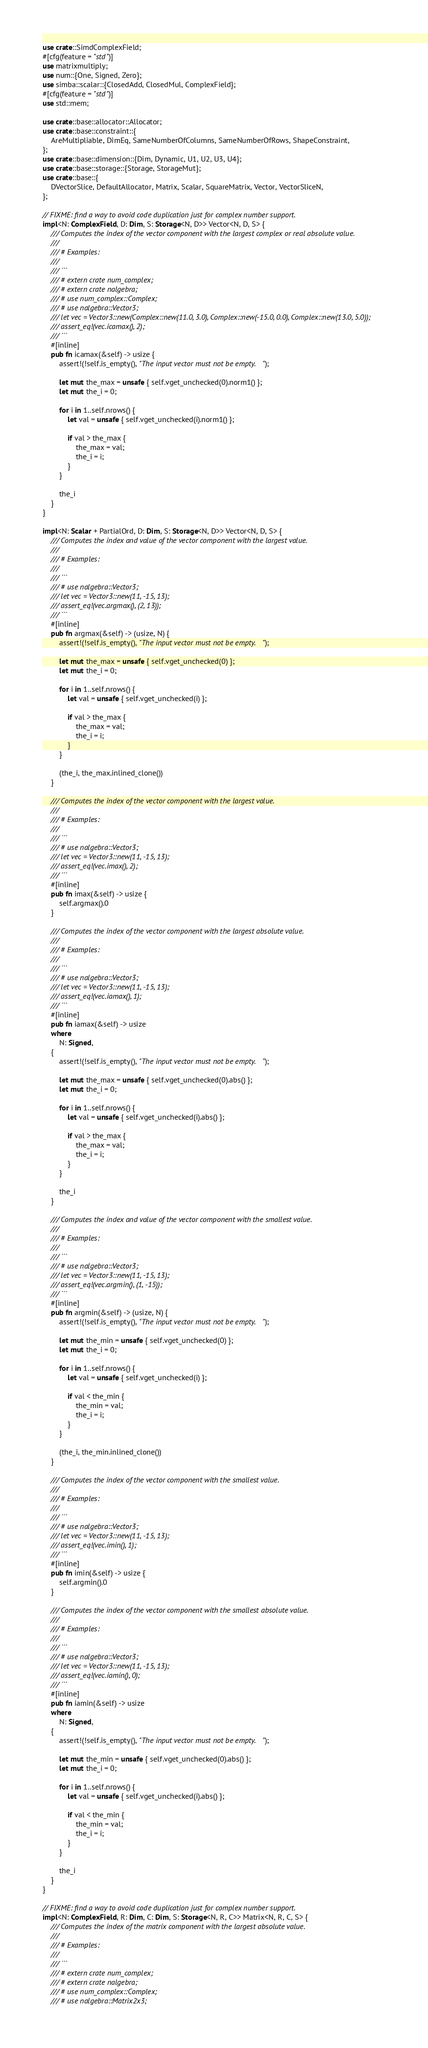Convert code to text. <code><loc_0><loc_0><loc_500><loc_500><_Rust_>use crate::SimdComplexField;
#[cfg(feature = "std")]
use matrixmultiply;
use num::{One, Signed, Zero};
use simba::scalar::{ClosedAdd, ClosedMul, ComplexField};
#[cfg(feature = "std")]
use std::mem;

use crate::base::allocator::Allocator;
use crate::base::constraint::{
    AreMultipliable, DimEq, SameNumberOfColumns, SameNumberOfRows, ShapeConstraint,
};
use crate::base::dimension::{Dim, Dynamic, U1, U2, U3, U4};
use crate::base::storage::{Storage, StorageMut};
use crate::base::{
    DVectorSlice, DefaultAllocator, Matrix, Scalar, SquareMatrix, Vector, VectorSliceN,
};

// FIXME: find a way to avoid code duplication just for complex number support.
impl<N: ComplexField, D: Dim, S: Storage<N, D>> Vector<N, D, S> {
    /// Computes the index of the vector component with the largest complex or real absolute value.
    ///
    /// # Examples:
    ///
    /// ```
    /// # extern crate num_complex;
    /// # extern crate nalgebra;
    /// # use num_complex::Complex;
    /// # use nalgebra::Vector3;
    /// let vec = Vector3::new(Complex::new(11.0, 3.0), Complex::new(-15.0, 0.0), Complex::new(13.0, 5.0));
    /// assert_eq!(vec.icamax(), 2);
    /// ```
    #[inline]
    pub fn icamax(&self) -> usize {
        assert!(!self.is_empty(), "The input vector must not be empty.");

        let mut the_max = unsafe { self.vget_unchecked(0).norm1() };
        let mut the_i = 0;

        for i in 1..self.nrows() {
            let val = unsafe { self.vget_unchecked(i).norm1() };

            if val > the_max {
                the_max = val;
                the_i = i;
            }
        }

        the_i
    }
}

impl<N: Scalar + PartialOrd, D: Dim, S: Storage<N, D>> Vector<N, D, S> {
    /// Computes the index and value of the vector component with the largest value.
    ///
    /// # Examples:
    ///
    /// ```
    /// # use nalgebra::Vector3;
    /// let vec = Vector3::new(11, -15, 13);
    /// assert_eq!(vec.argmax(), (2, 13));
    /// ```
    #[inline]
    pub fn argmax(&self) -> (usize, N) {
        assert!(!self.is_empty(), "The input vector must not be empty.");

        let mut the_max = unsafe { self.vget_unchecked(0) };
        let mut the_i = 0;

        for i in 1..self.nrows() {
            let val = unsafe { self.vget_unchecked(i) };

            if val > the_max {
                the_max = val;
                the_i = i;
            }
        }

        (the_i, the_max.inlined_clone())
    }

    /// Computes the index of the vector component with the largest value.
    ///
    /// # Examples:
    ///
    /// ```
    /// # use nalgebra::Vector3;
    /// let vec = Vector3::new(11, -15, 13);
    /// assert_eq!(vec.imax(), 2);
    /// ```
    #[inline]
    pub fn imax(&self) -> usize {
        self.argmax().0
    }

    /// Computes the index of the vector component with the largest absolute value.
    ///
    /// # Examples:
    ///
    /// ```
    /// # use nalgebra::Vector3;
    /// let vec = Vector3::new(11, -15, 13);
    /// assert_eq!(vec.iamax(), 1);
    /// ```
    #[inline]
    pub fn iamax(&self) -> usize
    where
        N: Signed,
    {
        assert!(!self.is_empty(), "The input vector must not be empty.");

        let mut the_max = unsafe { self.vget_unchecked(0).abs() };
        let mut the_i = 0;

        for i in 1..self.nrows() {
            let val = unsafe { self.vget_unchecked(i).abs() };

            if val > the_max {
                the_max = val;
                the_i = i;
            }
        }

        the_i
    }

    /// Computes the index and value of the vector component with the smallest value.
    ///
    /// # Examples:
    ///
    /// ```
    /// # use nalgebra::Vector3;
    /// let vec = Vector3::new(11, -15, 13);
    /// assert_eq!(vec.argmin(), (1, -15));
    /// ```
    #[inline]
    pub fn argmin(&self) -> (usize, N) {
        assert!(!self.is_empty(), "The input vector must not be empty.");

        let mut the_min = unsafe { self.vget_unchecked(0) };
        let mut the_i = 0;

        for i in 1..self.nrows() {
            let val = unsafe { self.vget_unchecked(i) };

            if val < the_min {
                the_min = val;
                the_i = i;
            }
        }

        (the_i, the_min.inlined_clone())
    }

    /// Computes the index of the vector component with the smallest value.
    ///
    /// # Examples:
    ///
    /// ```
    /// # use nalgebra::Vector3;
    /// let vec = Vector3::new(11, -15, 13);
    /// assert_eq!(vec.imin(), 1);
    /// ```
    #[inline]
    pub fn imin(&self) -> usize {
        self.argmin().0
    }

    /// Computes the index of the vector component with the smallest absolute value.
    ///
    /// # Examples:
    ///
    /// ```
    /// # use nalgebra::Vector3;
    /// let vec = Vector3::new(11, -15, 13);
    /// assert_eq!(vec.iamin(), 0);
    /// ```
    #[inline]
    pub fn iamin(&self) -> usize
    where
        N: Signed,
    {
        assert!(!self.is_empty(), "The input vector must not be empty.");

        let mut the_min = unsafe { self.vget_unchecked(0).abs() };
        let mut the_i = 0;

        for i in 1..self.nrows() {
            let val = unsafe { self.vget_unchecked(i).abs() };

            if val < the_min {
                the_min = val;
                the_i = i;
            }
        }

        the_i
    }
}

// FIXME: find a way to avoid code duplication just for complex number support.
impl<N: ComplexField, R: Dim, C: Dim, S: Storage<N, R, C>> Matrix<N, R, C, S> {
    /// Computes the index of the matrix component with the largest absolute value.
    ///
    /// # Examples:
    ///
    /// ```
    /// # extern crate num_complex;
    /// # extern crate nalgebra;
    /// # use num_complex::Complex;
    /// # use nalgebra::Matrix2x3;</code> 